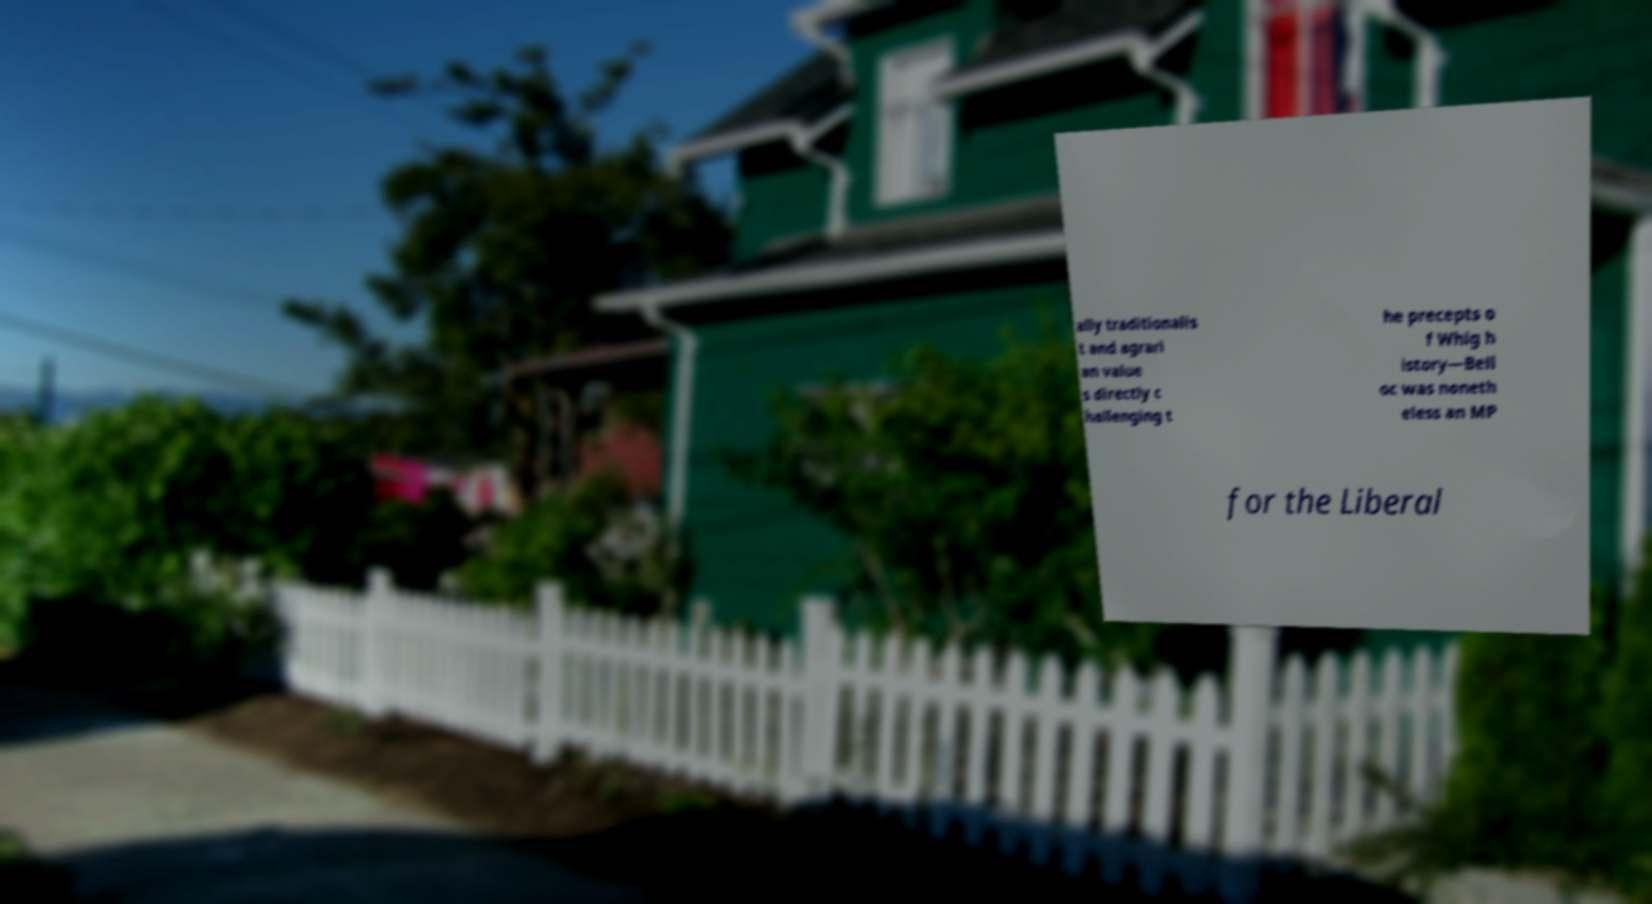Can you accurately transcribe the text from the provided image for me? ally traditionalis t and agrari an value s directly c hallenging t he precepts o f Whig h istory—Bell oc was noneth eless an MP for the Liberal 